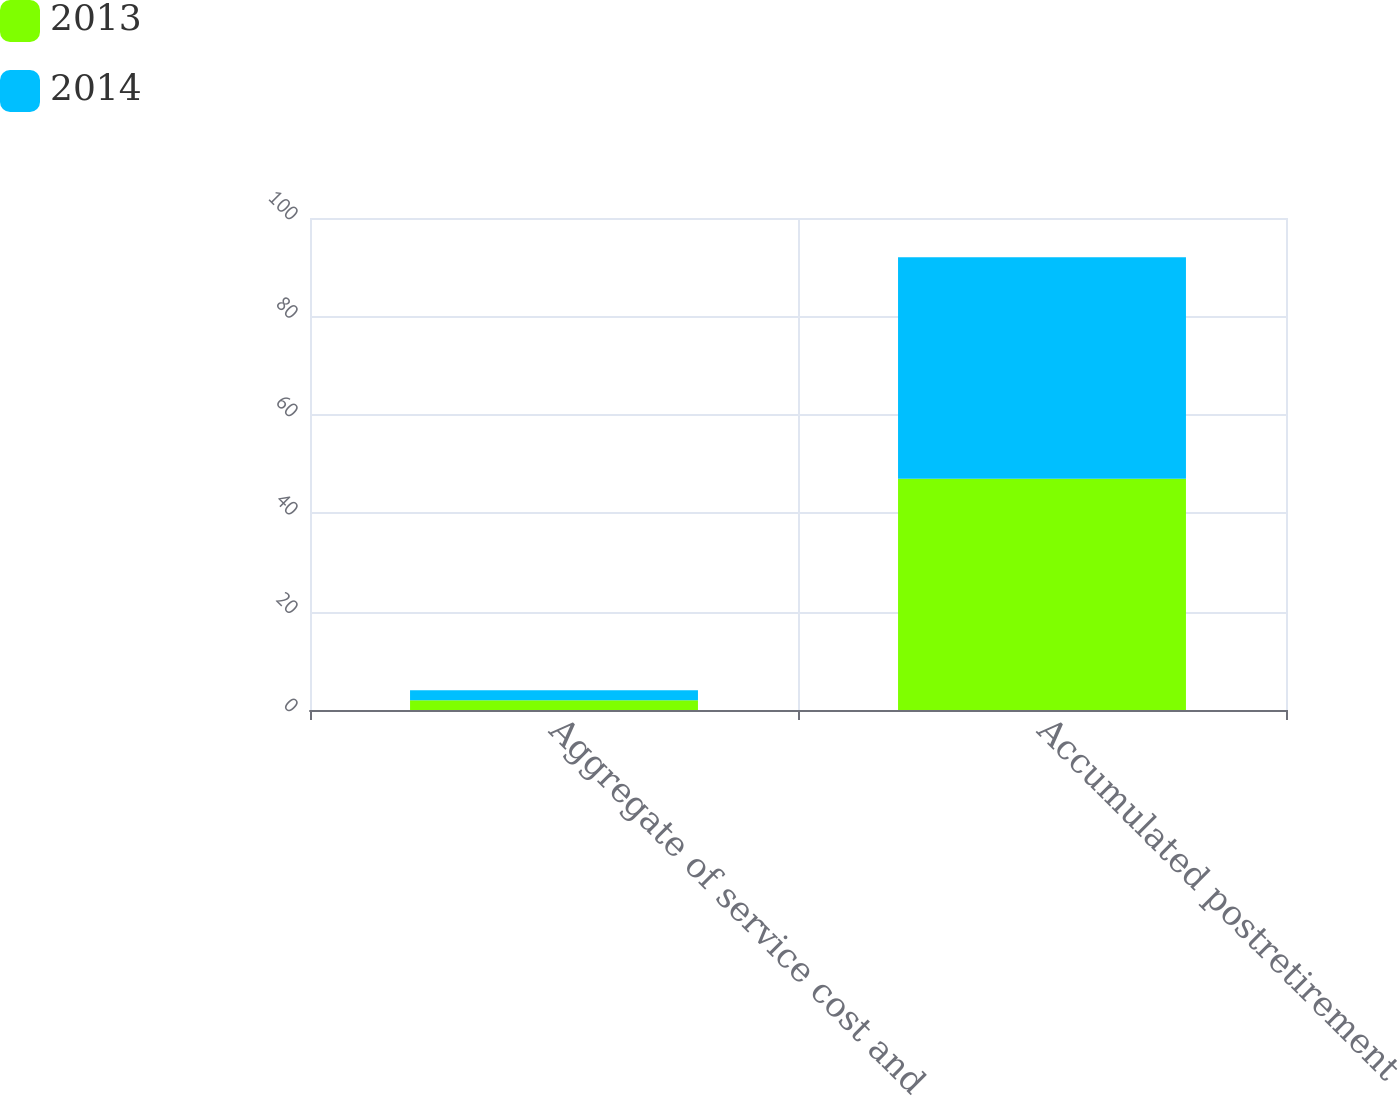Convert chart to OTSL. <chart><loc_0><loc_0><loc_500><loc_500><stacked_bar_chart><ecel><fcel>Aggregate of service cost and<fcel>Accumulated postretirement<nl><fcel>2013<fcel>2<fcel>47<nl><fcel>2014<fcel>2<fcel>45<nl></chart> 